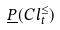<formula> <loc_0><loc_0><loc_500><loc_500>\underline { P } ( C l _ { t } ^ { \leq } )</formula> 